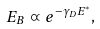Convert formula to latex. <formula><loc_0><loc_0><loc_500><loc_500>E _ { B } \varpropto e ^ { - \gamma _ { D } E ^ { * } } ,</formula> 